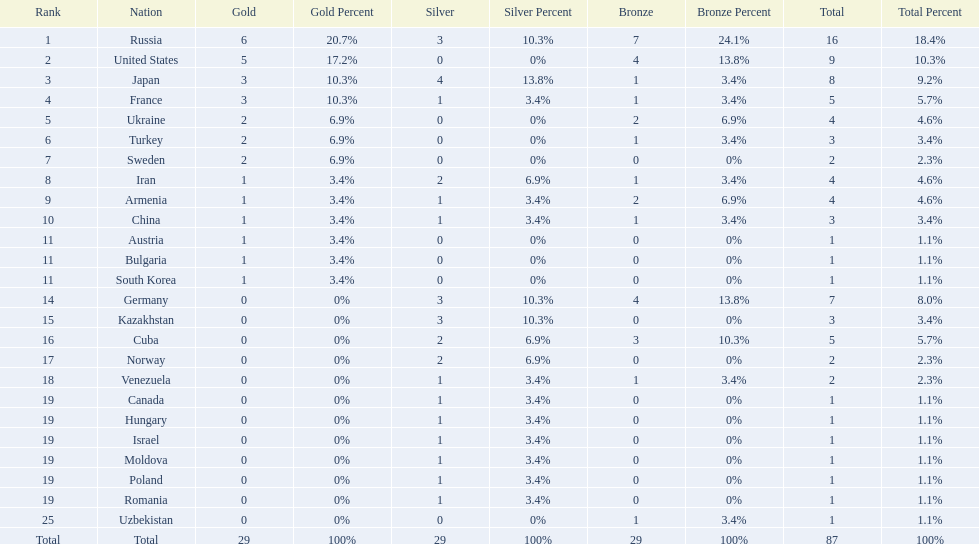Which countries competed in the 1995 world wrestling championships? Russia, United States, Japan, France, Ukraine, Turkey, Sweden, Iran, Armenia, China, Austria, Bulgaria, South Korea, Germany, Kazakhstan, Cuba, Norway, Venezuela, Canada, Hungary, Israel, Moldova, Poland, Romania, Uzbekistan. What country won only one medal? Austria, Bulgaria, South Korea, Canada, Hungary, Israel, Moldova, Poland, Romania, Uzbekistan. Which of these won a bronze medal? Uzbekistan. 